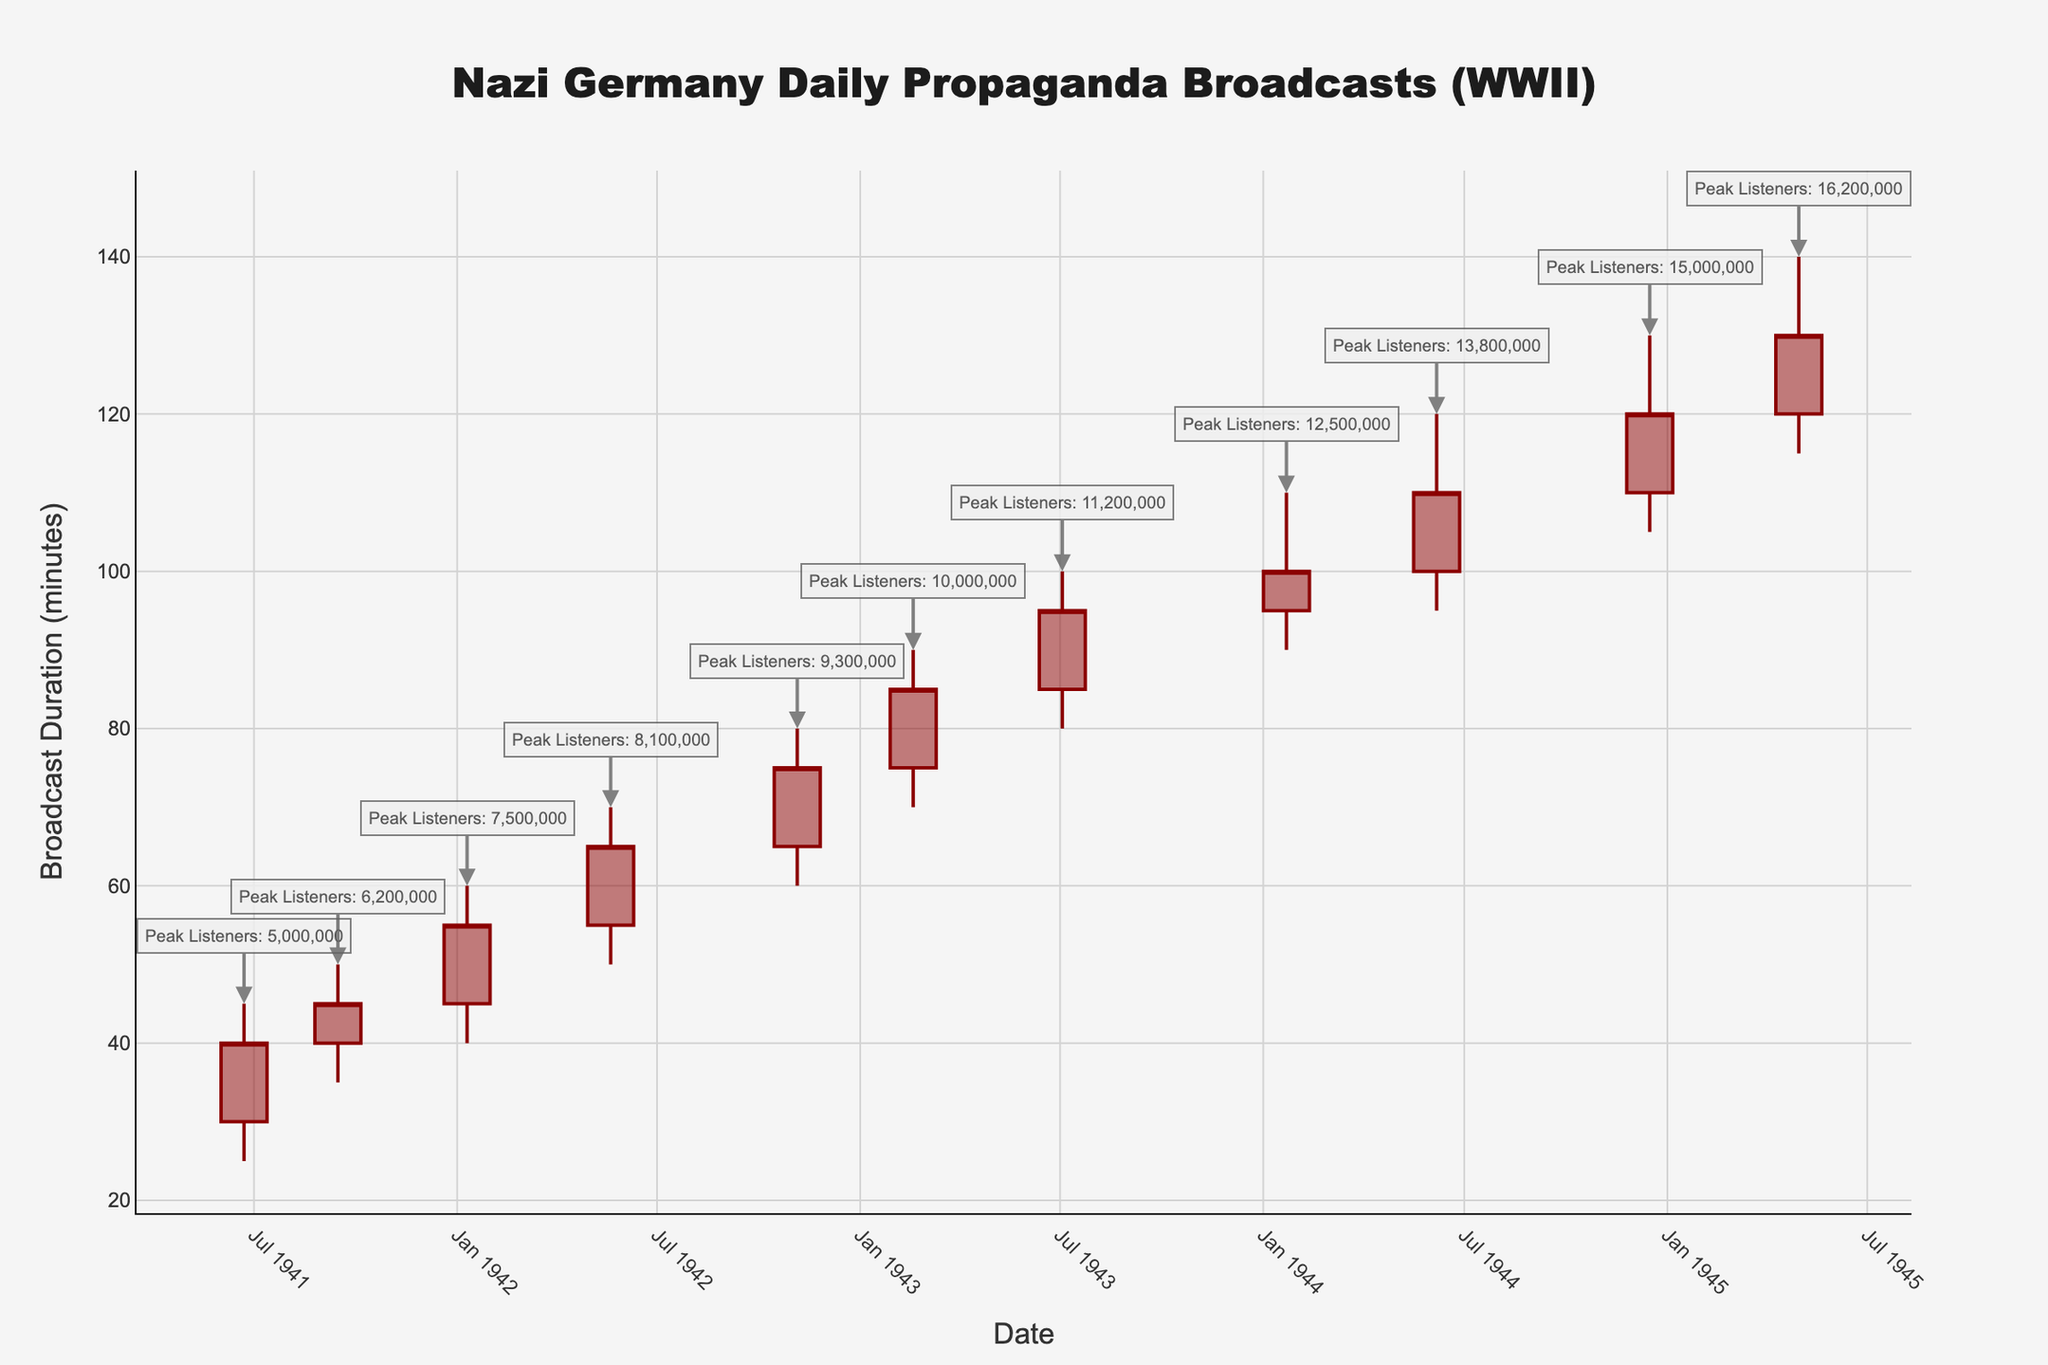How many data points are displayed in the figure? The figure shows a time-series chart from 1941 to 1945, with each point representing a specific date. Counting the dates listed in the data, there are 11 data points in total.
Answer: 11 What is the maximum broadcast duration recorded in the chart? The maximum broadcast duration is represented by the highest "High" value on the Y-axis, which is 140 minutes on 1945-04-30.
Answer: 140 minutes Between which dates did the broadcast duration see the largest increase? By examining the difference in "Close" values from one date to another, the largest increase is observed between the dates 1944-01-22 (100 minutes) and 1944-06-06 (110 minutes), showing an increase of 10 minutes.
Answer: 1944-01-22 to 1944-06-06 Which date had the highest peak listener estimate, and what was that estimate? The volume information annotated on the chart shows the highest peak listener estimate on 1945-04-30, with 16,200,000 listeners.
Answer: 1945-04-30, 16,200,000 listeners How does the broadcast duration trend over time? Generally, the broadcast duration appears to increase over time from June 1941 to April 1945, as indicated by the rising "Close" values at each data point.
Answer: Increasing trend What is the average peak listener estimate across all these dates? Adding all peak listener numbers: 5M + 6.2M + 7.5M + 8.1M + 9.3M + 10M + 11.2M + 12.5M + 13.8M + 15M + 16.2M = 104.8M. Divide by 11 data points: 104.8M / 11 ≈ 9.53M.
Answer: Approximately 9,530,000 listeners On what date did the broadcast duration first reach or exceed 100 minutes? By examining the "Close" values, the first date the broadcast duration reaches or exceeds 100 minutes is 1944-01-22.
Answer: 1944-01-22 Which data point marks the start of the highest upward trend in broadcast duration? The largest continuous increase in the "Close" value starts from 1944-01-22 (100 minutes) and continues upwards, peaking at 1945-04-30 (130 minutes). The point marking the start is 1944-01-22.
Answer: 1944-01-22 How many times did the broadcast duration decrease between data points, and during which intervals? Broadcast duration decreased from June 1941 to September 1941 and from June 1944 to December 1944.
Answer: 2 times: 1941-06-22 to 1941-09-15, 1944-06-06 to 1944-12-16 